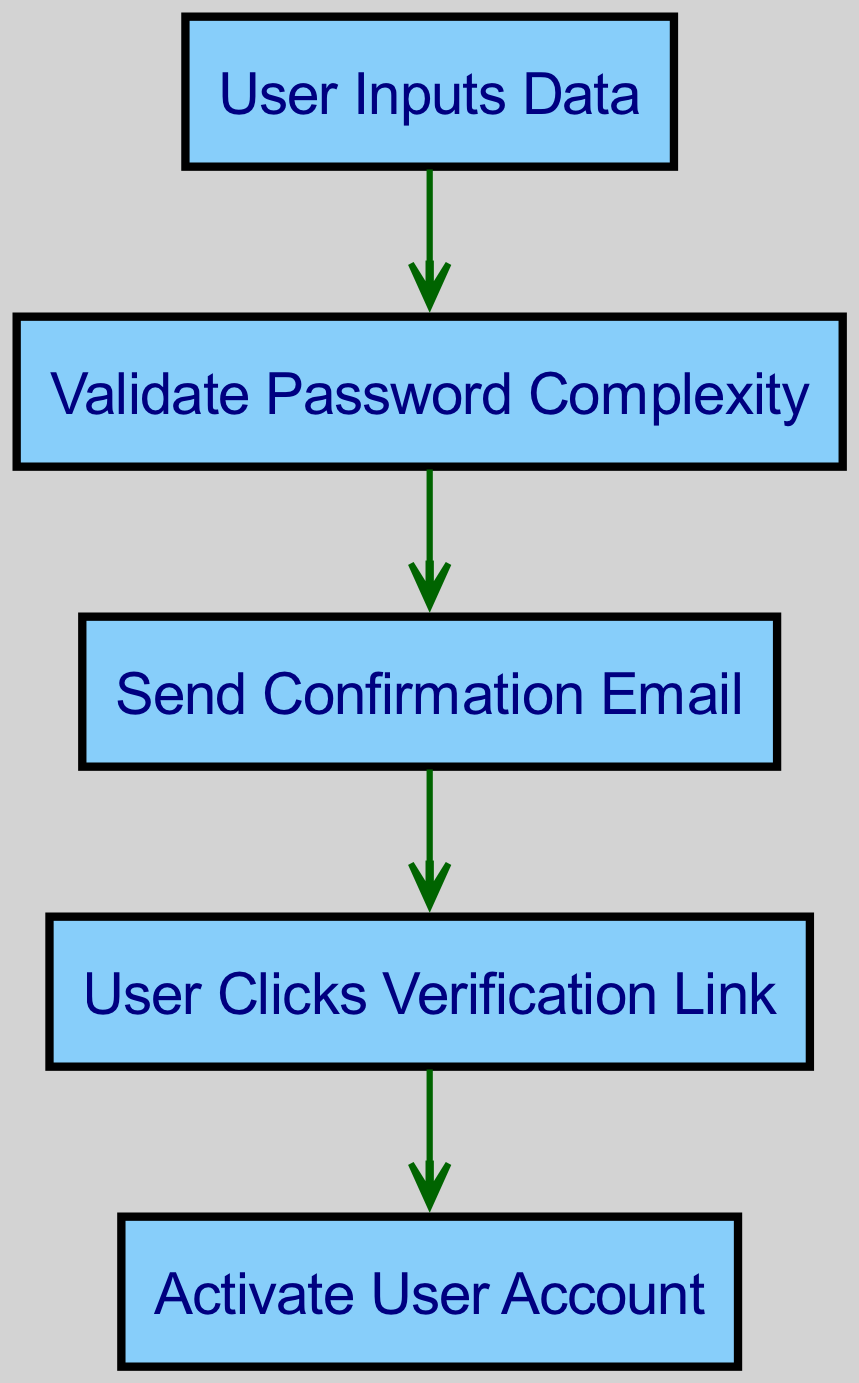What is the first step in the user registration workflow? The diagram indicates that the first step in the user registration workflow is "User Inputs Data." This is the initial action point for a new user registering on the web application.
Answer: User Inputs Data How many nodes are present in the diagram? By counting each unique step or action represented in the diagram, we find a total of five nodes: User Inputs Data, Validate Password Complexity, Send Confirmation Email, User Clicks Verification Link, and Activate User Account.
Answer: 5 Which step follows Password Validation? The edge directly connects "PasswordValidation" to "EmailConfirmation," indicating that after validating the password's complexity, the subsequent step is to send a confirmation email.
Answer: Send Confirmation Email What action is taken after sending the confirmation email? According to the directed edge from "EmailConfirmation" to "EmailVerification," the action that follows sending the email is for the user to click the verification link provided in that email.
Answer: User Clicks Verification Link What is the last step in the registration process? The final step in the directed graph, as indicated by the edge leading from "EmailVerification" to "AccountActivation," is to activate the user account. This concludes the registration workflow.
Answer: Activate User Account How many edges connect the nodes in the diagram? The diagram shows four directed edges, which represent the flow from one step to the next: AccountCreation to PasswordValidation, PasswordValidation to EmailConfirmation, EmailConfirmation to EmailVerification, and EmailVerification to AccountActivation.
Answer: 4 What type of graph is used to represent this workflow? The diagram is specifically a "Directed Graph," as it visually represents the directed flow of steps in the user registration process through nodes and directed edges that indicate the sequence of actions.
Answer: Directed Graph What is the relationship between "EmailConfirmation" and "EmailVerification"? The relationship is that "EmailConfirmation" directly leads to "EmailVerification," indicating that upon sending a confirmation email, the next action is for the user to verify their email by clicking the provided link.
Answer: Direct connection 